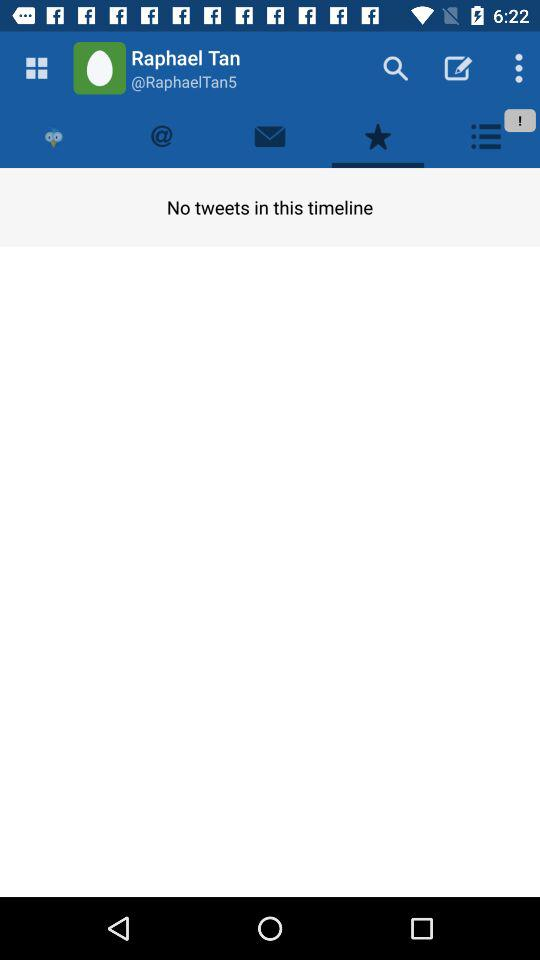What is the user name? The user name is Raphael Tan. 